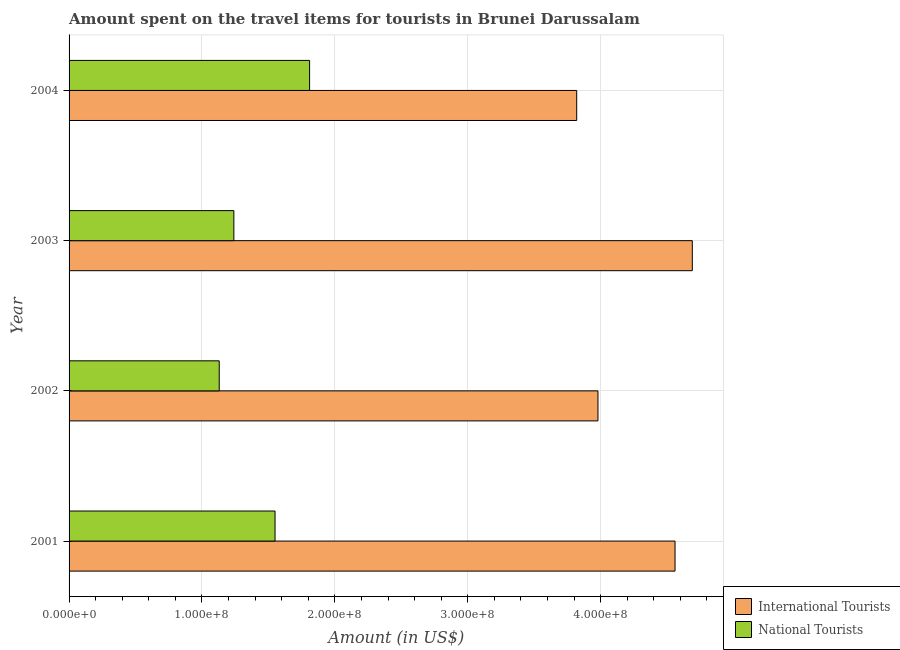How many different coloured bars are there?
Keep it short and to the point. 2. How many groups of bars are there?
Give a very brief answer. 4. Are the number of bars per tick equal to the number of legend labels?
Offer a terse response. Yes. Are the number of bars on each tick of the Y-axis equal?
Your answer should be compact. Yes. How many bars are there on the 3rd tick from the top?
Provide a short and direct response. 2. What is the label of the 2nd group of bars from the top?
Your answer should be compact. 2003. In how many cases, is the number of bars for a given year not equal to the number of legend labels?
Offer a very short reply. 0. What is the amount spent on travel items of international tourists in 2002?
Your response must be concise. 3.98e+08. Across all years, what is the maximum amount spent on travel items of international tourists?
Keep it short and to the point. 4.69e+08. Across all years, what is the minimum amount spent on travel items of international tourists?
Ensure brevity in your answer.  3.82e+08. In which year was the amount spent on travel items of national tourists maximum?
Your answer should be compact. 2004. What is the total amount spent on travel items of national tourists in the graph?
Your answer should be compact. 5.73e+08. What is the difference between the amount spent on travel items of international tourists in 2002 and that in 2003?
Give a very brief answer. -7.10e+07. What is the difference between the amount spent on travel items of national tourists in 2003 and the amount spent on travel items of international tourists in 2001?
Provide a succinct answer. -3.32e+08. What is the average amount spent on travel items of national tourists per year?
Provide a short and direct response. 1.43e+08. In the year 2002, what is the difference between the amount spent on travel items of international tourists and amount spent on travel items of national tourists?
Make the answer very short. 2.85e+08. What is the ratio of the amount spent on travel items of international tourists in 2002 to that in 2003?
Offer a terse response. 0.85. Is the amount spent on travel items of international tourists in 2002 less than that in 2004?
Keep it short and to the point. No. What is the difference between the highest and the second highest amount spent on travel items of national tourists?
Your answer should be very brief. 2.60e+07. What is the difference between the highest and the lowest amount spent on travel items of national tourists?
Keep it short and to the point. 6.80e+07. Is the sum of the amount spent on travel items of national tourists in 2001 and 2002 greater than the maximum amount spent on travel items of international tourists across all years?
Offer a very short reply. No. What does the 1st bar from the top in 2002 represents?
Provide a short and direct response. National Tourists. What does the 1st bar from the bottom in 2001 represents?
Ensure brevity in your answer.  International Tourists. How many years are there in the graph?
Make the answer very short. 4. What is the difference between two consecutive major ticks on the X-axis?
Provide a short and direct response. 1.00e+08. Are the values on the major ticks of X-axis written in scientific E-notation?
Your answer should be compact. Yes. Does the graph contain any zero values?
Keep it short and to the point. No. Does the graph contain grids?
Keep it short and to the point. Yes. Where does the legend appear in the graph?
Your response must be concise. Bottom right. How are the legend labels stacked?
Provide a succinct answer. Vertical. What is the title of the graph?
Ensure brevity in your answer.  Amount spent on the travel items for tourists in Brunei Darussalam. What is the label or title of the Y-axis?
Keep it short and to the point. Year. What is the Amount (in US$) in International Tourists in 2001?
Your answer should be very brief. 4.56e+08. What is the Amount (in US$) of National Tourists in 2001?
Ensure brevity in your answer.  1.55e+08. What is the Amount (in US$) in International Tourists in 2002?
Keep it short and to the point. 3.98e+08. What is the Amount (in US$) in National Tourists in 2002?
Your response must be concise. 1.13e+08. What is the Amount (in US$) of International Tourists in 2003?
Ensure brevity in your answer.  4.69e+08. What is the Amount (in US$) in National Tourists in 2003?
Provide a succinct answer. 1.24e+08. What is the Amount (in US$) in International Tourists in 2004?
Your answer should be compact. 3.82e+08. What is the Amount (in US$) of National Tourists in 2004?
Your answer should be compact. 1.81e+08. Across all years, what is the maximum Amount (in US$) in International Tourists?
Your response must be concise. 4.69e+08. Across all years, what is the maximum Amount (in US$) of National Tourists?
Provide a short and direct response. 1.81e+08. Across all years, what is the minimum Amount (in US$) in International Tourists?
Your answer should be very brief. 3.82e+08. Across all years, what is the minimum Amount (in US$) in National Tourists?
Your answer should be very brief. 1.13e+08. What is the total Amount (in US$) in International Tourists in the graph?
Ensure brevity in your answer.  1.70e+09. What is the total Amount (in US$) in National Tourists in the graph?
Ensure brevity in your answer.  5.73e+08. What is the difference between the Amount (in US$) of International Tourists in 2001 and that in 2002?
Offer a very short reply. 5.80e+07. What is the difference between the Amount (in US$) in National Tourists in 2001 and that in 2002?
Make the answer very short. 4.20e+07. What is the difference between the Amount (in US$) of International Tourists in 2001 and that in 2003?
Provide a succinct answer. -1.30e+07. What is the difference between the Amount (in US$) of National Tourists in 2001 and that in 2003?
Offer a very short reply. 3.10e+07. What is the difference between the Amount (in US$) in International Tourists in 2001 and that in 2004?
Offer a very short reply. 7.40e+07. What is the difference between the Amount (in US$) of National Tourists in 2001 and that in 2004?
Offer a very short reply. -2.60e+07. What is the difference between the Amount (in US$) of International Tourists in 2002 and that in 2003?
Ensure brevity in your answer.  -7.10e+07. What is the difference between the Amount (in US$) in National Tourists in 2002 and that in 2003?
Offer a terse response. -1.10e+07. What is the difference between the Amount (in US$) of International Tourists in 2002 and that in 2004?
Your response must be concise. 1.60e+07. What is the difference between the Amount (in US$) in National Tourists in 2002 and that in 2004?
Keep it short and to the point. -6.80e+07. What is the difference between the Amount (in US$) of International Tourists in 2003 and that in 2004?
Your answer should be compact. 8.70e+07. What is the difference between the Amount (in US$) of National Tourists in 2003 and that in 2004?
Offer a terse response. -5.70e+07. What is the difference between the Amount (in US$) of International Tourists in 2001 and the Amount (in US$) of National Tourists in 2002?
Give a very brief answer. 3.43e+08. What is the difference between the Amount (in US$) of International Tourists in 2001 and the Amount (in US$) of National Tourists in 2003?
Keep it short and to the point. 3.32e+08. What is the difference between the Amount (in US$) in International Tourists in 2001 and the Amount (in US$) in National Tourists in 2004?
Make the answer very short. 2.75e+08. What is the difference between the Amount (in US$) in International Tourists in 2002 and the Amount (in US$) in National Tourists in 2003?
Provide a succinct answer. 2.74e+08. What is the difference between the Amount (in US$) in International Tourists in 2002 and the Amount (in US$) in National Tourists in 2004?
Your response must be concise. 2.17e+08. What is the difference between the Amount (in US$) in International Tourists in 2003 and the Amount (in US$) in National Tourists in 2004?
Ensure brevity in your answer.  2.88e+08. What is the average Amount (in US$) in International Tourists per year?
Offer a very short reply. 4.26e+08. What is the average Amount (in US$) of National Tourists per year?
Your answer should be compact. 1.43e+08. In the year 2001, what is the difference between the Amount (in US$) in International Tourists and Amount (in US$) in National Tourists?
Offer a terse response. 3.01e+08. In the year 2002, what is the difference between the Amount (in US$) of International Tourists and Amount (in US$) of National Tourists?
Keep it short and to the point. 2.85e+08. In the year 2003, what is the difference between the Amount (in US$) in International Tourists and Amount (in US$) in National Tourists?
Offer a terse response. 3.45e+08. In the year 2004, what is the difference between the Amount (in US$) in International Tourists and Amount (in US$) in National Tourists?
Offer a very short reply. 2.01e+08. What is the ratio of the Amount (in US$) in International Tourists in 2001 to that in 2002?
Offer a terse response. 1.15. What is the ratio of the Amount (in US$) of National Tourists in 2001 to that in 2002?
Offer a very short reply. 1.37. What is the ratio of the Amount (in US$) of International Tourists in 2001 to that in 2003?
Make the answer very short. 0.97. What is the ratio of the Amount (in US$) in National Tourists in 2001 to that in 2003?
Your answer should be compact. 1.25. What is the ratio of the Amount (in US$) in International Tourists in 2001 to that in 2004?
Ensure brevity in your answer.  1.19. What is the ratio of the Amount (in US$) of National Tourists in 2001 to that in 2004?
Provide a short and direct response. 0.86. What is the ratio of the Amount (in US$) of International Tourists in 2002 to that in 2003?
Provide a succinct answer. 0.85. What is the ratio of the Amount (in US$) in National Tourists in 2002 to that in 2003?
Give a very brief answer. 0.91. What is the ratio of the Amount (in US$) of International Tourists in 2002 to that in 2004?
Your answer should be very brief. 1.04. What is the ratio of the Amount (in US$) in National Tourists in 2002 to that in 2004?
Your answer should be compact. 0.62. What is the ratio of the Amount (in US$) of International Tourists in 2003 to that in 2004?
Your answer should be compact. 1.23. What is the ratio of the Amount (in US$) of National Tourists in 2003 to that in 2004?
Provide a succinct answer. 0.69. What is the difference between the highest and the second highest Amount (in US$) of International Tourists?
Offer a terse response. 1.30e+07. What is the difference between the highest and the second highest Amount (in US$) in National Tourists?
Provide a short and direct response. 2.60e+07. What is the difference between the highest and the lowest Amount (in US$) of International Tourists?
Offer a very short reply. 8.70e+07. What is the difference between the highest and the lowest Amount (in US$) of National Tourists?
Your answer should be very brief. 6.80e+07. 